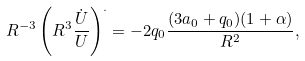Convert formula to latex. <formula><loc_0><loc_0><loc_500><loc_500>R ^ { - 3 } \left ( R ^ { 3 } \frac { \dot { U } } { U } \right ) ^ { . } = - 2 q _ { 0 } \frac { ( 3 a _ { 0 } + q _ { 0 } ) ( 1 + \alpha ) } { R ^ { 2 } } ,</formula> 